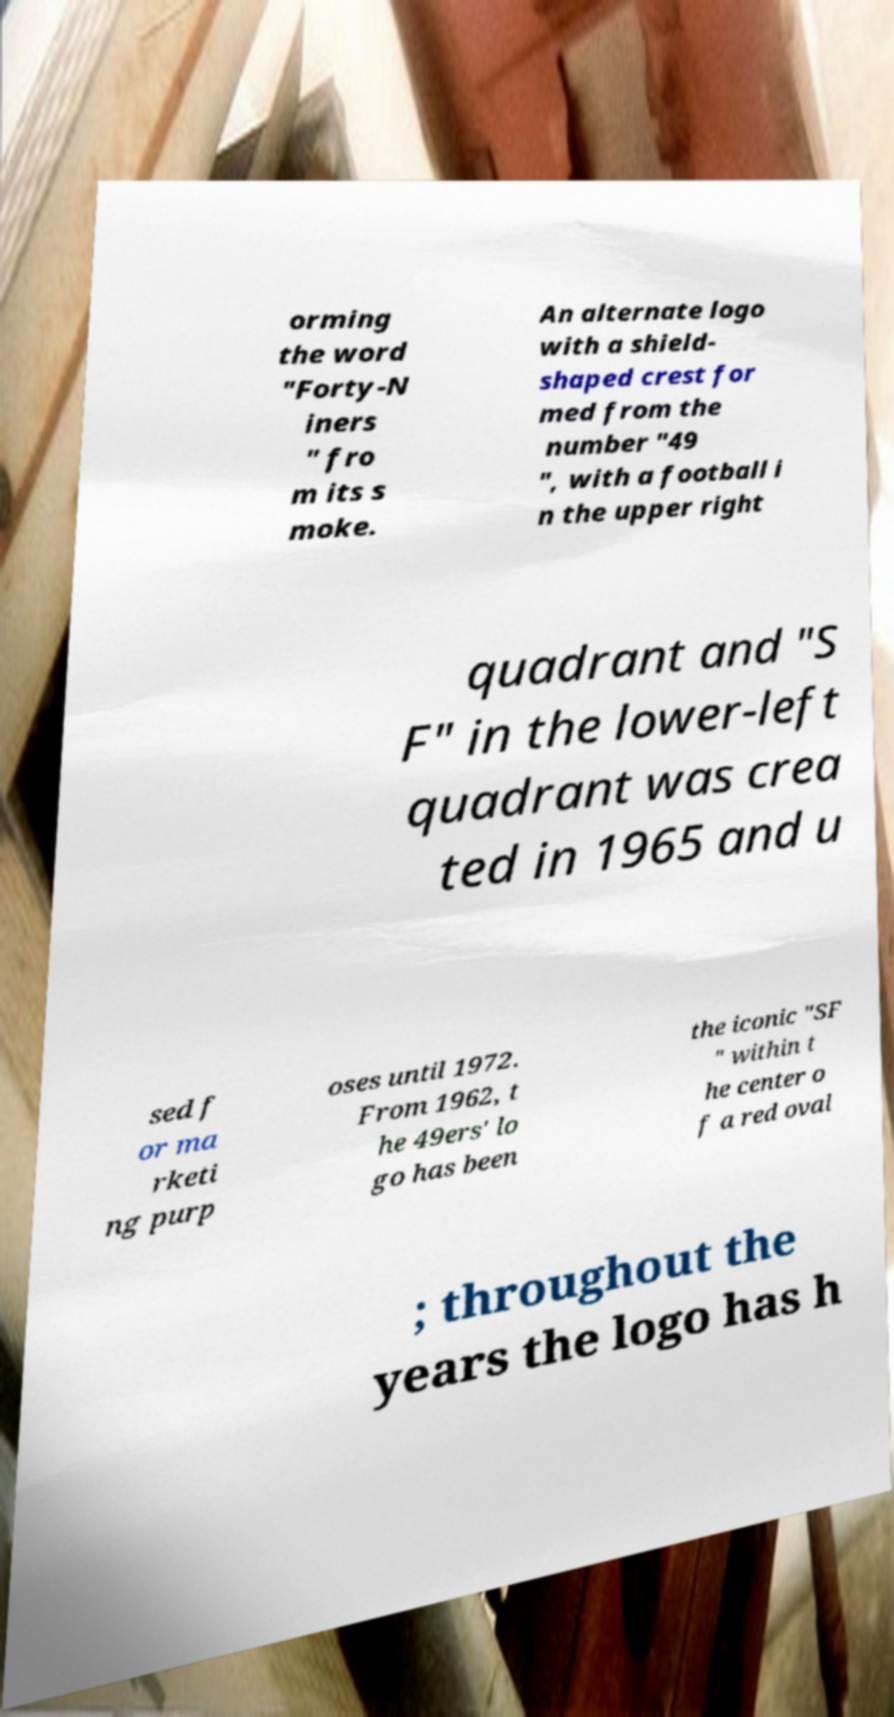Could you extract and type out the text from this image? orming the word "Forty-N iners " fro m its s moke. An alternate logo with a shield- shaped crest for med from the number "49 ", with a football i n the upper right quadrant and "S F" in the lower-left quadrant was crea ted in 1965 and u sed f or ma rketi ng purp oses until 1972. From 1962, t he 49ers' lo go has been the iconic "SF " within t he center o f a red oval ; throughout the years the logo has h 